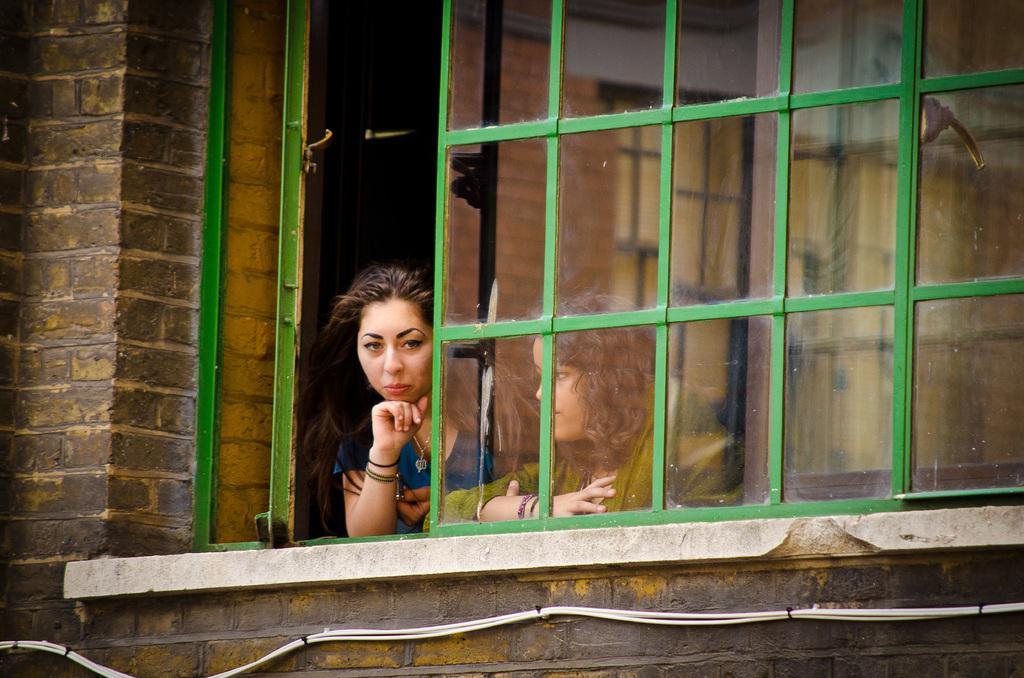Could you give a brief overview of what you see in this image? In this image we can see two people standing near the window. we can also see a wall and some wires. 